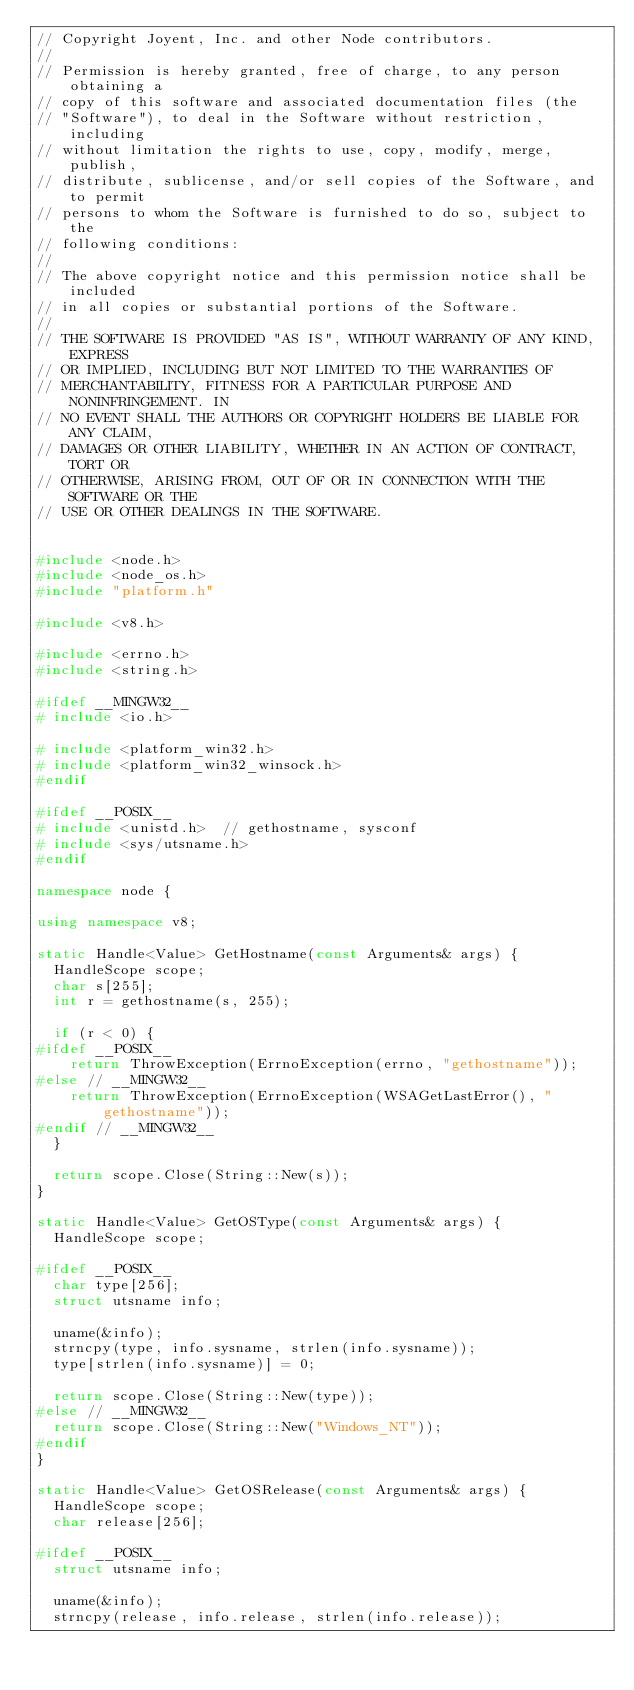<code> <loc_0><loc_0><loc_500><loc_500><_C++_>// Copyright Joyent, Inc. and other Node contributors.
//
// Permission is hereby granted, free of charge, to any person obtaining a
// copy of this software and associated documentation files (the
// "Software"), to deal in the Software without restriction, including
// without limitation the rights to use, copy, modify, merge, publish,
// distribute, sublicense, and/or sell copies of the Software, and to permit
// persons to whom the Software is furnished to do so, subject to the
// following conditions:
//
// The above copyright notice and this permission notice shall be included
// in all copies or substantial portions of the Software.
//
// THE SOFTWARE IS PROVIDED "AS IS", WITHOUT WARRANTY OF ANY KIND, EXPRESS
// OR IMPLIED, INCLUDING BUT NOT LIMITED TO THE WARRANTIES OF
// MERCHANTABILITY, FITNESS FOR A PARTICULAR PURPOSE AND NONINFRINGEMENT. IN
// NO EVENT SHALL THE AUTHORS OR COPYRIGHT HOLDERS BE LIABLE FOR ANY CLAIM,
// DAMAGES OR OTHER LIABILITY, WHETHER IN AN ACTION OF CONTRACT, TORT OR
// OTHERWISE, ARISING FROM, OUT OF OR IN CONNECTION WITH THE SOFTWARE OR THE
// USE OR OTHER DEALINGS IN THE SOFTWARE.


#include <node.h>
#include <node_os.h>
#include "platform.h"

#include <v8.h>

#include <errno.h>
#include <string.h>

#ifdef __MINGW32__
# include <io.h>

# include <platform_win32.h>
# include <platform_win32_winsock.h>
#endif

#ifdef __POSIX__
# include <unistd.h>  // gethostname, sysconf
# include <sys/utsname.h>
#endif

namespace node {

using namespace v8;

static Handle<Value> GetHostname(const Arguments& args) {
  HandleScope scope;
  char s[255];
  int r = gethostname(s, 255);

  if (r < 0) {
#ifdef __POSIX__
    return ThrowException(ErrnoException(errno, "gethostname"));
#else // __MINGW32__
    return ThrowException(ErrnoException(WSAGetLastError(), "gethostname"));
#endif // __MINGW32__
  }

  return scope.Close(String::New(s));
}

static Handle<Value> GetOSType(const Arguments& args) {
  HandleScope scope;

#ifdef __POSIX__
  char type[256];
  struct utsname info;

  uname(&info);
  strncpy(type, info.sysname, strlen(info.sysname));
  type[strlen(info.sysname)] = 0;

  return scope.Close(String::New(type));
#else // __MINGW32__
  return scope.Close(String::New("Windows_NT"));
#endif
}

static Handle<Value> GetOSRelease(const Arguments& args) {
  HandleScope scope;
  char release[256];

#ifdef __POSIX__
  struct utsname info;

  uname(&info);
  strncpy(release, info.release, strlen(info.release));</code> 